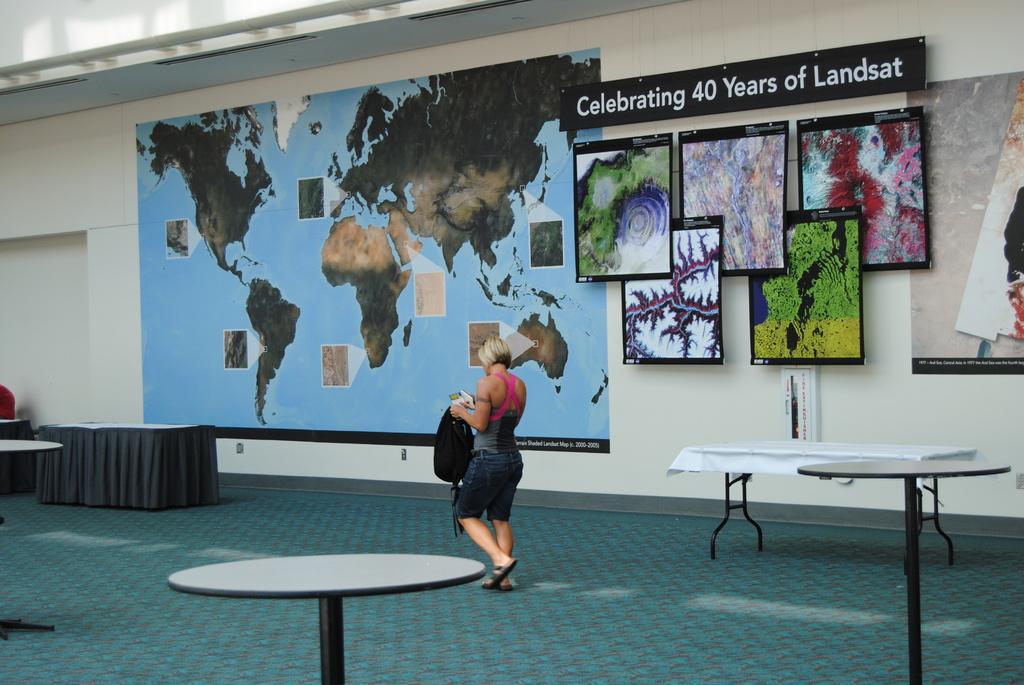Please provide a concise description of this image. In this image, we can see a person walking and holding some objects and a bag. In the background, there is a poster and we can see some boards on the wall and there are tables and stands and there is a rod. At the bottom, there is floor. 